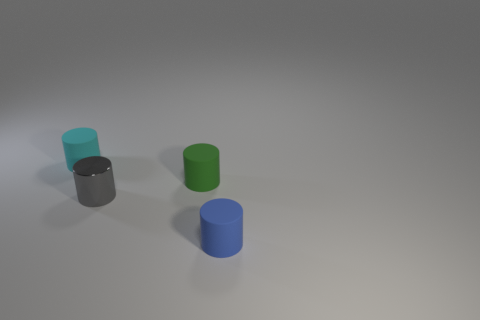Are the cylinders reflective, and can we guess the texture of their material? The cylinders exhibit a slight reflection, hinting at a somewhat shiny material, potentially a matte or satin finish. This kind of reflection suggests that the cylinders have a smooth surface but are not highly polished or glossy. 